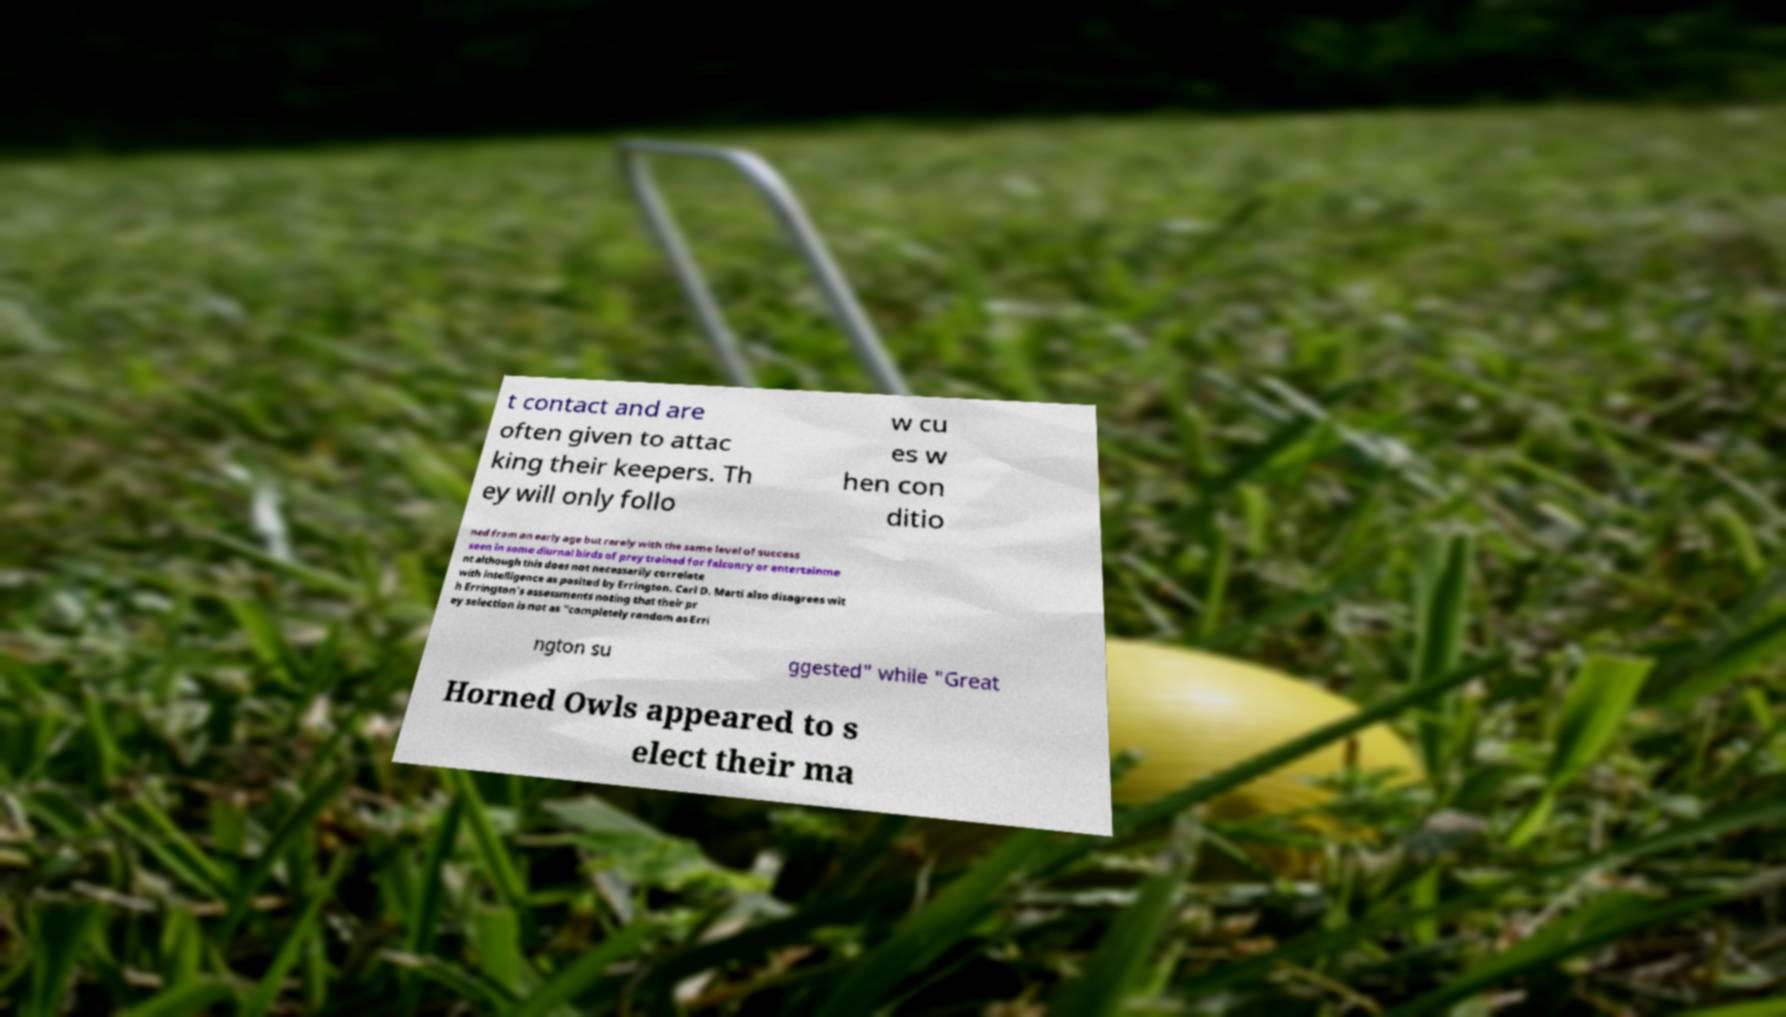There's text embedded in this image that I need extracted. Can you transcribe it verbatim? t contact and are often given to attac king their keepers. Th ey will only follo w cu es w hen con ditio ned from an early age but rarely with the same level of success seen in some diurnal birds of prey trained for falconry or entertainme nt although this does not necessarily correlate with intelligence as posited by Errington. Carl D. Marti also disagrees wit h Errington's assessments noting that their pr ey selection is not as "completely random as Erri ngton su ggested" while "Great Horned Owls appeared to s elect their ma 